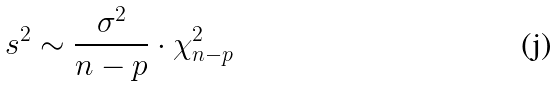Convert formula to latex. <formula><loc_0><loc_0><loc_500><loc_500>s ^ { 2 } \sim \frac { \sigma ^ { 2 } } { n - p } \cdot \chi _ { n - p } ^ { 2 }</formula> 